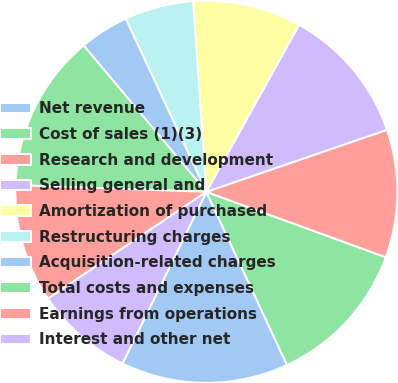<chart> <loc_0><loc_0><loc_500><loc_500><pie_chart><fcel>Net revenue<fcel>Cost of sales (1)(3)<fcel>Research and development<fcel>Selling general and<fcel>Amortization of purchased<fcel>Restructuring charges<fcel>Acquisition-related charges<fcel>Total costs and expenses<fcel>Earnings from operations<fcel>Interest and other net<nl><fcel>14.17%<fcel>12.5%<fcel>10.83%<fcel>11.67%<fcel>9.17%<fcel>5.83%<fcel>4.17%<fcel>13.33%<fcel>10.0%<fcel>8.33%<nl></chart> 